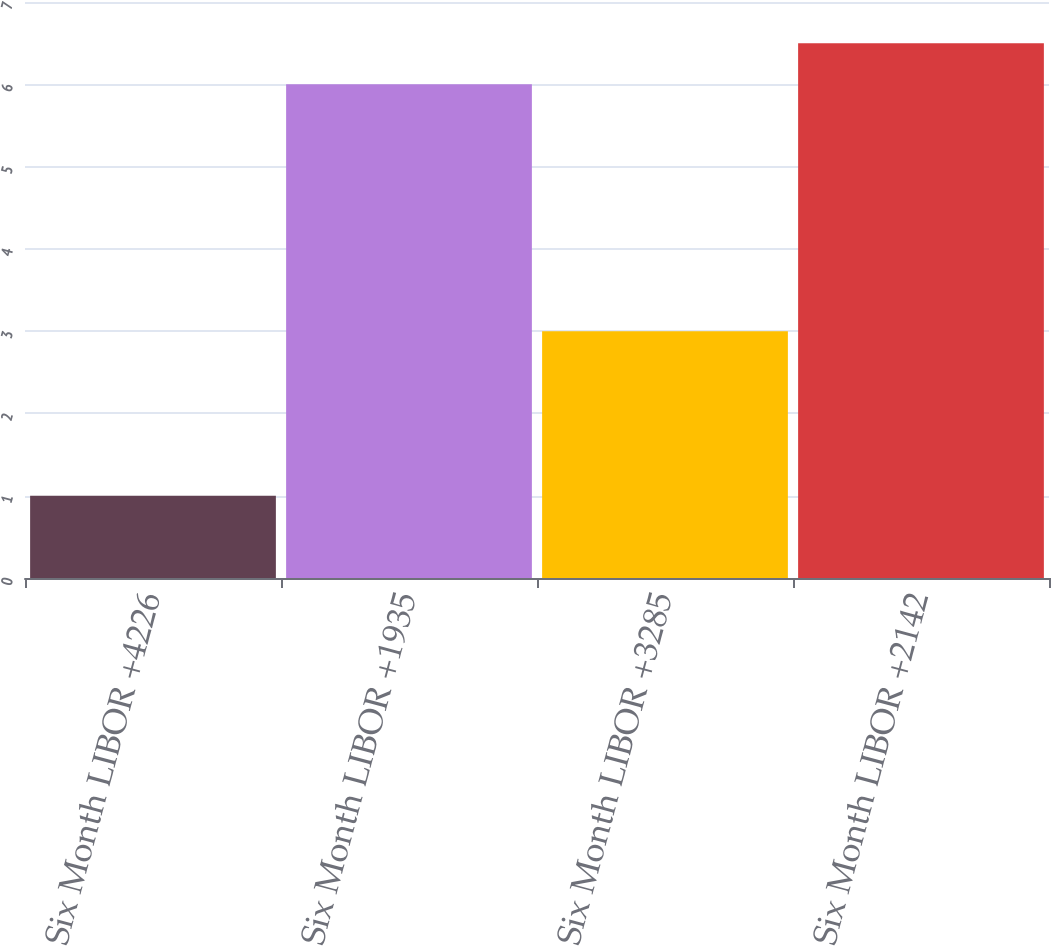Convert chart. <chart><loc_0><loc_0><loc_500><loc_500><bar_chart><fcel>Six Month LIBOR +4226<fcel>Six Month LIBOR +1935<fcel>Six Month LIBOR +3285<fcel>Six Month LIBOR +2142<nl><fcel>1<fcel>6<fcel>3<fcel>6.5<nl></chart> 